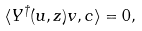<formula> <loc_0><loc_0><loc_500><loc_500>\langle Y ^ { \dag } ( u , z ) v , c \rangle = 0 ,</formula> 